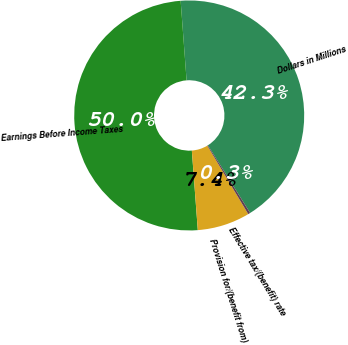Convert chart to OTSL. <chart><loc_0><loc_0><loc_500><loc_500><pie_chart><fcel>Dollars in Millions<fcel>Earnings Before Income Taxes<fcel>Provision for/(benefit from)<fcel>Effective tax/(benefit) rate<nl><fcel>42.29%<fcel>50.0%<fcel>7.39%<fcel>0.31%<nl></chart> 